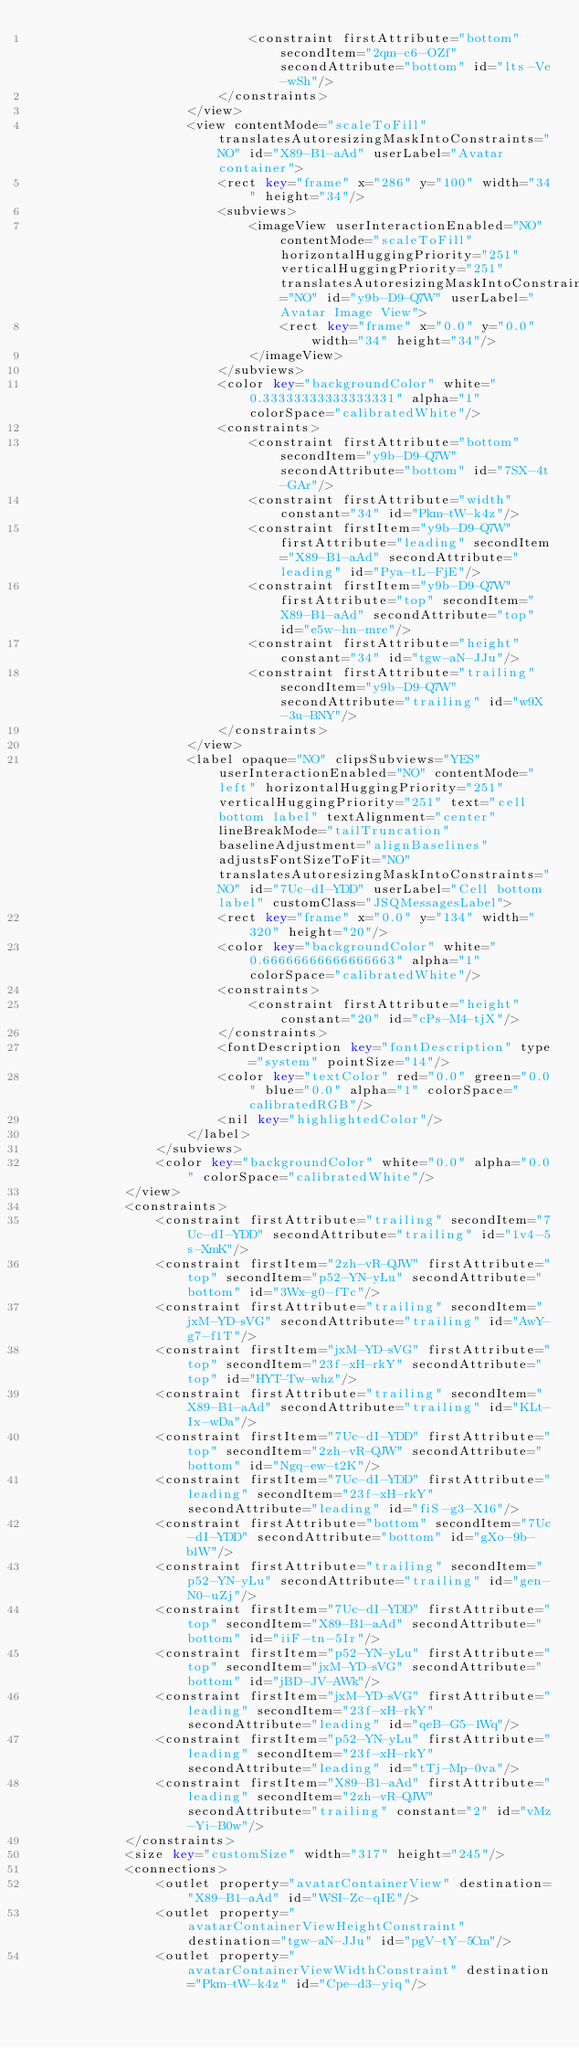<code> <loc_0><loc_0><loc_500><loc_500><_XML_>                            <constraint firstAttribute="bottom" secondItem="2qm-c6-OZf" secondAttribute="bottom" id="lts-Ve-wSh"/>
                        </constraints>
                    </view>
                    <view contentMode="scaleToFill" translatesAutoresizingMaskIntoConstraints="NO" id="X89-B1-aAd" userLabel="Avatar container">
                        <rect key="frame" x="286" y="100" width="34" height="34"/>
                        <subviews>
                            <imageView userInteractionEnabled="NO" contentMode="scaleToFill" horizontalHuggingPriority="251" verticalHuggingPriority="251" translatesAutoresizingMaskIntoConstraints="NO" id="y9b-D9-Q7W" userLabel="Avatar Image View">
                                <rect key="frame" x="0.0" y="0.0" width="34" height="34"/>
                            </imageView>
                        </subviews>
                        <color key="backgroundColor" white="0.33333333333333331" alpha="1" colorSpace="calibratedWhite"/>
                        <constraints>
                            <constraint firstAttribute="bottom" secondItem="y9b-D9-Q7W" secondAttribute="bottom" id="7SX-4t-GAr"/>
                            <constraint firstAttribute="width" constant="34" id="Pkm-tW-k4z"/>
                            <constraint firstItem="y9b-D9-Q7W" firstAttribute="leading" secondItem="X89-B1-aAd" secondAttribute="leading" id="Pya-tL-FjE"/>
                            <constraint firstItem="y9b-D9-Q7W" firstAttribute="top" secondItem="X89-B1-aAd" secondAttribute="top" id="e5w-hn-mre"/>
                            <constraint firstAttribute="height" constant="34" id="tgw-aN-JJu"/>
                            <constraint firstAttribute="trailing" secondItem="y9b-D9-Q7W" secondAttribute="trailing" id="w9X-3u-BNY"/>
                        </constraints>
                    </view>
                    <label opaque="NO" clipsSubviews="YES" userInteractionEnabled="NO" contentMode="left" horizontalHuggingPriority="251" verticalHuggingPriority="251" text="cell bottom label" textAlignment="center" lineBreakMode="tailTruncation" baselineAdjustment="alignBaselines" adjustsFontSizeToFit="NO" translatesAutoresizingMaskIntoConstraints="NO" id="7Uc-dI-YDD" userLabel="Cell bottom label" customClass="JSQMessagesLabel">
                        <rect key="frame" x="0.0" y="134" width="320" height="20"/>
                        <color key="backgroundColor" white="0.66666666666666663" alpha="1" colorSpace="calibratedWhite"/>
                        <constraints>
                            <constraint firstAttribute="height" constant="20" id="cPs-M4-tjX"/>
                        </constraints>
                        <fontDescription key="fontDescription" type="system" pointSize="14"/>
                        <color key="textColor" red="0.0" green="0.0" blue="0.0" alpha="1" colorSpace="calibratedRGB"/>
                        <nil key="highlightedColor"/>
                    </label>
                </subviews>
                <color key="backgroundColor" white="0.0" alpha="0.0" colorSpace="calibratedWhite"/>
            </view>
            <constraints>
                <constraint firstAttribute="trailing" secondItem="7Uc-dI-YDD" secondAttribute="trailing" id="1v4-5s-XmK"/>
                <constraint firstItem="2zh-vR-QJW" firstAttribute="top" secondItem="p52-YN-yLu" secondAttribute="bottom" id="3Wx-g0-fTc"/>
                <constraint firstAttribute="trailing" secondItem="jxM-YD-sVG" secondAttribute="trailing" id="AwY-g7-f1T"/>
                <constraint firstItem="jxM-YD-sVG" firstAttribute="top" secondItem="23f-xH-rkY" secondAttribute="top" id="HYT-Tw-whz"/>
                <constraint firstAttribute="trailing" secondItem="X89-B1-aAd" secondAttribute="trailing" id="KLt-Ix-wDa"/>
                <constraint firstItem="7Uc-dI-YDD" firstAttribute="top" secondItem="2zh-vR-QJW" secondAttribute="bottom" id="Ngq-ew-t2K"/>
                <constraint firstItem="7Uc-dI-YDD" firstAttribute="leading" secondItem="23f-xH-rkY" secondAttribute="leading" id="fiS-g3-X16"/>
                <constraint firstAttribute="bottom" secondItem="7Uc-dI-YDD" secondAttribute="bottom" id="gXo-9b-b1W"/>
                <constraint firstAttribute="trailing" secondItem="p52-YN-yLu" secondAttribute="trailing" id="gen-N0-uZj"/>
                <constraint firstItem="7Uc-dI-YDD" firstAttribute="top" secondItem="X89-B1-aAd" secondAttribute="bottom" id="iiF-tn-5Ir"/>
                <constraint firstItem="p52-YN-yLu" firstAttribute="top" secondItem="jxM-YD-sVG" secondAttribute="bottom" id="jBD-JV-AWk"/>
                <constraint firstItem="jxM-YD-sVG" firstAttribute="leading" secondItem="23f-xH-rkY" secondAttribute="leading" id="qeB-G5-1Wq"/>
                <constraint firstItem="p52-YN-yLu" firstAttribute="leading" secondItem="23f-xH-rkY" secondAttribute="leading" id="tTj-Mp-0va"/>
                <constraint firstItem="X89-B1-aAd" firstAttribute="leading" secondItem="2zh-vR-QJW" secondAttribute="trailing" constant="2" id="vMz-Yi-B0w"/>
            </constraints>
            <size key="customSize" width="317" height="245"/>
            <connections>
                <outlet property="avatarContainerView" destination="X89-B1-aAd" id="WSI-Zc-qIE"/>
                <outlet property="avatarContainerViewHeightConstraint" destination="tgw-aN-JJu" id="pgV-tY-5Cm"/>
                <outlet property="avatarContainerViewWidthConstraint" destination="Pkm-tW-k4z" id="Cpe-d3-yiq"/></code> 